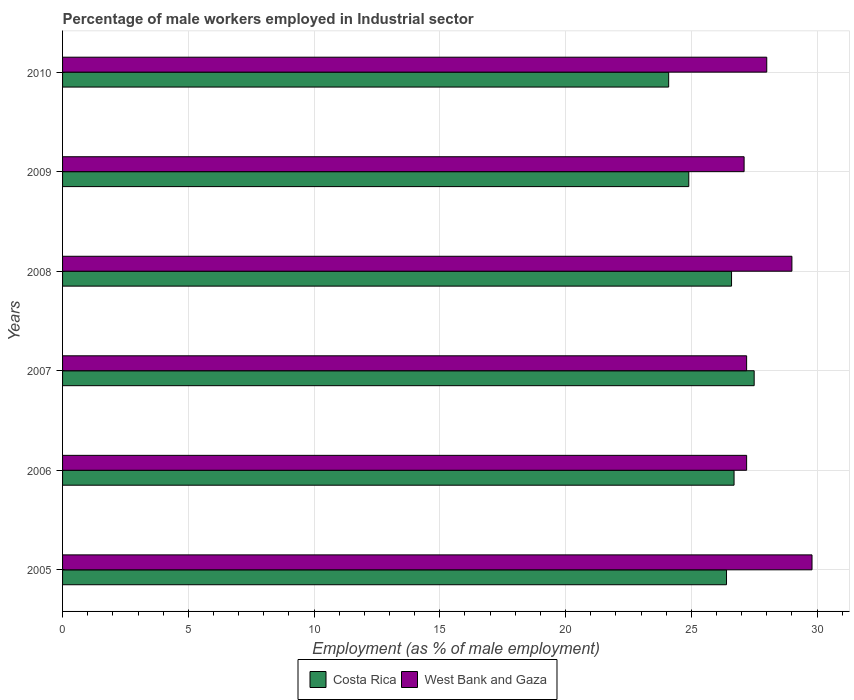How many different coloured bars are there?
Offer a very short reply. 2. How many groups of bars are there?
Give a very brief answer. 6. Are the number of bars per tick equal to the number of legend labels?
Offer a very short reply. Yes. How many bars are there on the 2nd tick from the top?
Keep it short and to the point. 2. What is the label of the 5th group of bars from the top?
Give a very brief answer. 2006. Across all years, what is the maximum percentage of male workers employed in Industrial sector in West Bank and Gaza?
Offer a very short reply. 29.8. Across all years, what is the minimum percentage of male workers employed in Industrial sector in Costa Rica?
Make the answer very short. 24.1. What is the total percentage of male workers employed in Industrial sector in West Bank and Gaza in the graph?
Offer a terse response. 168.3. What is the difference between the percentage of male workers employed in Industrial sector in West Bank and Gaza in 2005 and that in 2010?
Offer a terse response. 1.8. What is the difference between the percentage of male workers employed in Industrial sector in West Bank and Gaza in 2006 and the percentage of male workers employed in Industrial sector in Costa Rica in 2008?
Your response must be concise. 0.6. What is the average percentage of male workers employed in Industrial sector in Costa Rica per year?
Offer a very short reply. 26.03. In the year 2010, what is the difference between the percentage of male workers employed in Industrial sector in Costa Rica and percentage of male workers employed in Industrial sector in West Bank and Gaza?
Your response must be concise. -3.9. What is the ratio of the percentage of male workers employed in Industrial sector in Costa Rica in 2007 to that in 2009?
Offer a terse response. 1.1. Is the difference between the percentage of male workers employed in Industrial sector in Costa Rica in 2007 and 2009 greater than the difference between the percentage of male workers employed in Industrial sector in West Bank and Gaza in 2007 and 2009?
Give a very brief answer. Yes. What is the difference between the highest and the second highest percentage of male workers employed in Industrial sector in West Bank and Gaza?
Your response must be concise. 0.8. What is the difference between the highest and the lowest percentage of male workers employed in Industrial sector in Costa Rica?
Offer a very short reply. 3.4. In how many years, is the percentage of male workers employed in Industrial sector in West Bank and Gaza greater than the average percentage of male workers employed in Industrial sector in West Bank and Gaza taken over all years?
Your answer should be very brief. 2. Is the sum of the percentage of male workers employed in Industrial sector in Costa Rica in 2006 and 2008 greater than the maximum percentage of male workers employed in Industrial sector in West Bank and Gaza across all years?
Offer a very short reply. Yes. What does the 1st bar from the top in 2009 represents?
Give a very brief answer. West Bank and Gaza. What does the 2nd bar from the bottom in 2008 represents?
Your response must be concise. West Bank and Gaza. What is the difference between two consecutive major ticks on the X-axis?
Ensure brevity in your answer.  5. Are the values on the major ticks of X-axis written in scientific E-notation?
Your answer should be compact. No. Does the graph contain any zero values?
Your response must be concise. No. Where does the legend appear in the graph?
Provide a short and direct response. Bottom center. How are the legend labels stacked?
Your answer should be compact. Horizontal. What is the title of the graph?
Make the answer very short. Percentage of male workers employed in Industrial sector. Does "Mauritania" appear as one of the legend labels in the graph?
Keep it short and to the point. No. What is the label or title of the X-axis?
Provide a succinct answer. Employment (as % of male employment). What is the Employment (as % of male employment) in Costa Rica in 2005?
Provide a short and direct response. 26.4. What is the Employment (as % of male employment) in West Bank and Gaza in 2005?
Provide a short and direct response. 29.8. What is the Employment (as % of male employment) in Costa Rica in 2006?
Offer a very short reply. 26.7. What is the Employment (as % of male employment) in West Bank and Gaza in 2006?
Offer a terse response. 27.2. What is the Employment (as % of male employment) of Costa Rica in 2007?
Your response must be concise. 27.5. What is the Employment (as % of male employment) of West Bank and Gaza in 2007?
Your answer should be compact. 27.2. What is the Employment (as % of male employment) in Costa Rica in 2008?
Your response must be concise. 26.6. What is the Employment (as % of male employment) of Costa Rica in 2009?
Offer a terse response. 24.9. What is the Employment (as % of male employment) in West Bank and Gaza in 2009?
Provide a succinct answer. 27.1. What is the Employment (as % of male employment) of Costa Rica in 2010?
Give a very brief answer. 24.1. What is the Employment (as % of male employment) in West Bank and Gaza in 2010?
Keep it short and to the point. 28. Across all years, what is the maximum Employment (as % of male employment) of West Bank and Gaza?
Your answer should be compact. 29.8. Across all years, what is the minimum Employment (as % of male employment) in Costa Rica?
Keep it short and to the point. 24.1. Across all years, what is the minimum Employment (as % of male employment) of West Bank and Gaza?
Ensure brevity in your answer.  27.1. What is the total Employment (as % of male employment) of Costa Rica in the graph?
Ensure brevity in your answer.  156.2. What is the total Employment (as % of male employment) of West Bank and Gaza in the graph?
Offer a very short reply. 168.3. What is the difference between the Employment (as % of male employment) of Costa Rica in 2005 and that in 2006?
Offer a terse response. -0.3. What is the difference between the Employment (as % of male employment) in West Bank and Gaza in 2005 and that in 2006?
Give a very brief answer. 2.6. What is the difference between the Employment (as % of male employment) in Costa Rica in 2005 and that in 2007?
Provide a short and direct response. -1.1. What is the difference between the Employment (as % of male employment) of West Bank and Gaza in 2005 and that in 2010?
Keep it short and to the point. 1.8. What is the difference between the Employment (as % of male employment) of Costa Rica in 2006 and that in 2007?
Keep it short and to the point. -0.8. What is the difference between the Employment (as % of male employment) in Costa Rica in 2006 and that in 2008?
Offer a terse response. 0.1. What is the difference between the Employment (as % of male employment) in Costa Rica in 2006 and that in 2009?
Make the answer very short. 1.8. What is the difference between the Employment (as % of male employment) of Costa Rica in 2006 and that in 2010?
Give a very brief answer. 2.6. What is the difference between the Employment (as % of male employment) in Costa Rica in 2007 and that in 2008?
Your answer should be compact. 0.9. What is the difference between the Employment (as % of male employment) in West Bank and Gaza in 2007 and that in 2008?
Offer a very short reply. -1.8. What is the difference between the Employment (as % of male employment) in West Bank and Gaza in 2008 and that in 2010?
Provide a short and direct response. 1. What is the difference between the Employment (as % of male employment) of Costa Rica in 2005 and the Employment (as % of male employment) of West Bank and Gaza in 2006?
Give a very brief answer. -0.8. What is the difference between the Employment (as % of male employment) of Costa Rica in 2005 and the Employment (as % of male employment) of West Bank and Gaza in 2007?
Make the answer very short. -0.8. What is the difference between the Employment (as % of male employment) in Costa Rica in 2005 and the Employment (as % of male employment) in West Bank and Gaza in 2008?
Your response must be concise. -2.6. What is the difference between the Employment (as % of male employment) of Costa Rica in 2006 and the Employment (as % of male employment) of West Bank and Gaza in 2009?
Give a very brief answer. -0.4. What is the difference between the Employment (as % of male employment) in Costa Rica in 2007 and the Employment (as % of male employment) in West Bank and Gaza in 2008?
Your answer should be compact. -1.5. What is the difference between the Employment (as % of male employment) of Costa Rica in 2008 and the Employment (as % of male employment) of West Bank and Gaza in 2009?
Provide a succinct answer. -0.5. What is the difference between the Employment (as % of male employment) in Costa Rica in 2009 and the Employment (as % of male employment) in West Bank and Gaza in 2010?
Make the answer very short. -3.1. What is the average Employment (as % of male employment) in Costa Rica per year?
Your answer should be very brief. 26.03. What is the average Employment (as % of male employment) of West Bank and Gaza per year?
Offer a very short reply. 28.05. In the year 2005, what is the difference between the Employment (as % of male employment) of Costa Rica and Employment (as % of male employment) of West Bank and Gaza?
Offer a terse response. -3.4. In the year 2006, what is the difference between the Employment (as % of male employment) of Costa Rica and Employment (as % of male employment) of West Bank and Gaza?
Keep it short and to the point. -0.5. In the year 2007, what is the difference between the Employment (as % of male employment) in Costa Rica and Employment (as % of male employment) in West Bank and Gaza?
Ensure brevity in your answer.  0.3. In the year 2008, what is the difference between the Employment (as % of male employment) in Costa Rica and Employment (as % of male employment) in West Bank and Gaza?
Ensure brevity in your answer.  -2.4. In the year 2010, what is the difference between the Employment (as % of male employment) in Costa Rica and Employment (as % of male employment) in West Bank and Gaza?
Provide a short and direct response. -3.9. What is the ratio of the Employment (as % of male employment) of West Bank and Gaza in 2005 to that in 2006?
Provide a succinct answer. 1.1. What is the ratio of the Employment (as % of male employment) in Costa Rica in 2005 to that in 2007?
Offer a very short reply. 0.96. What is the ratio of the Employment (as % of male employment) of West Bank and Gaza in 2005 to that in 2007?
Offer a very short reply. 1.1. What is the ratio of the Employment (as % of male employment) in Costa Rica in 2005 to that in 2008?
Provide a short and direct response. 0.99. What is the ratio of the Employment (as % of male employment) of West Bank and Gaza in 2005 to that in 2008?
Make the answer very short. 1.03. What is the ratio of the Employment (as % of male employment) in Costa Rica in 2005 to that in 2009?
Your answer should be compact. 1.06. What is the ratio of the Employment (as % of male employment) of West Bank and Gaza in 2005 to that in 2009?
Keep it short and to the point. 1.1. What is the ratio of the Employment (as % of male employment) in Costa Rica in 2005 to that in 2010?
Your response must be concise. 1.1. What is the ratio of the Employment (as % of male employment) of West Bank and Gaza in 2005 to that in 2010?
Your response must be concise. 1.06. What is the ratio of the Employment (as % of male employment) of Costa Rica in 2006 to that in 2007?
Keep it short and to the point. 0.97. What is the ratio of the Employment (as % of male employment) of West Bank and Gaza in 2006 to that in 2008?
Offer a very short reply. 0.94. What is the ratio of the Employment (as % of male employment) of Costa Rica in 2006 to that in 2009?
Provide a succinct answer. 1.07. What is the ratio of the Employment (as % of male employment) of Costa Rica in 2006 to that in 2010?
Your answer should be very brief. 1.11. What is the ratio of the Employment (as % of male employment) in West Bank and Gaza in 2006 to that in 2010?
Your answer should be compact. 0.97. What is the ratio of the Employment (as % of male employment) in Costa Rica in 2007 to that in 2008?
Ensure brevity in your answer.  1.03. What is the ratio of the Employment (as % of male employment) in West Bank and Gaza in 2007 to that in 2008?
Offer a very short reply. 0.94. What is the ratio of the Employment (as % of male employment) of Costa Rica in 2007 to that in 2009?
Your answer should be compact. 1.1. What is the ratio of the Employment (as % of male employment) of Costa Rica in 2007 to that in 2010?
Provide a short and direct response. 1.14. What is the ratio of the Employment (as % of male employment) in West Bank and Gaza in 2007 to that in 2010?
Your response must be concise. 0.97. What is the ratio of the Employment (as % of male employment) of Costa Rica in 2008 to that in 2009?
Offer a very short reply. 1.07. What is the ratio of the Employment (as % of male employment) in West Bank and Gaza in 2008 to that in 2009?
Your answer should be compact. 1.07. What is the ratio of the Employment (as % of male employment) of Costa Rica in 2008 to that in 2010?
Your answer should be compact. 1.1. What is the ratio of the Employment (as % of male employment) in West Bank and Gaza in 2008 to that in 2010?
Offer a very short reply. 1.04. What is the ratio of the Employment (as % of male employment) in Costa Rica in 2009 to that in 2010?
Make the answer very short. 1.03. What is the ratio of the Employment (as % of male employment) in West Bank and Gaza in 2009 to that in 2010?
Keep it short and to the point. 0.97. What is the difference between the highest and the second highest Employment (as % of male employment) of West Bank and Gaza?
Ensure brevity in your answer.  0.8. What is the difference between the highest and the lowest Employment (as % of male employment) in West Bank and Gaza?
Make the answer very short. 2.7. 